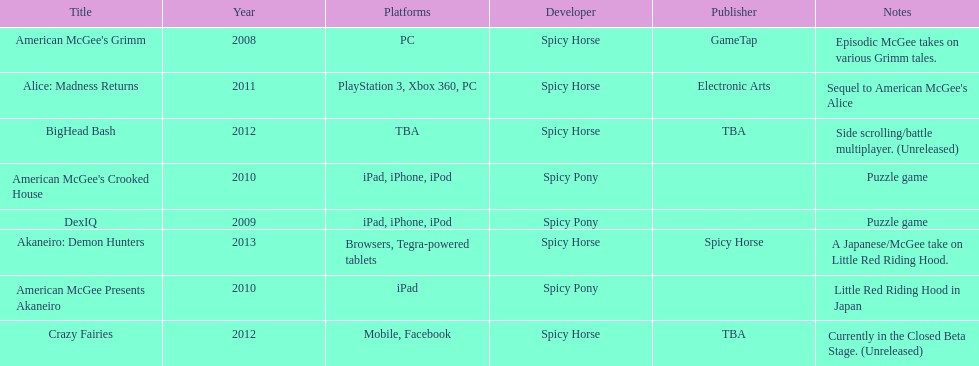What is the first title on this chart? American McGee's Grimm. 